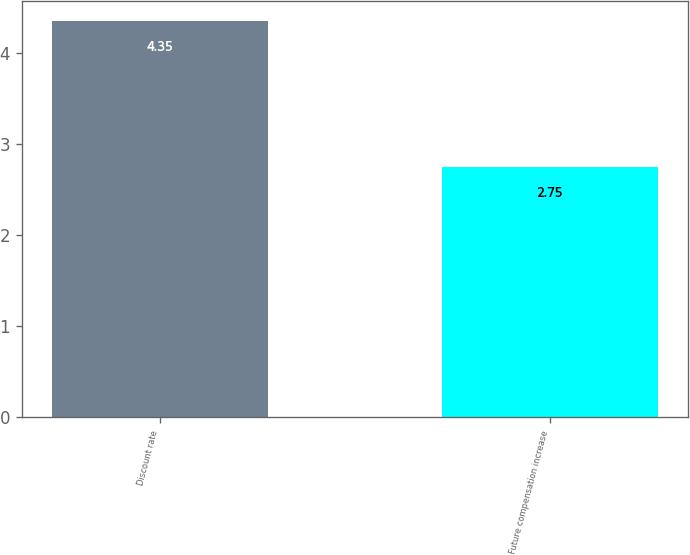<chart> <loc_0><loc_0><loc_500><loc_500><bar_chart><fcel>Discount rate<fcel>Future compensation increase<nl><fcel>4.35<fcel>2.75<nl></chart> 